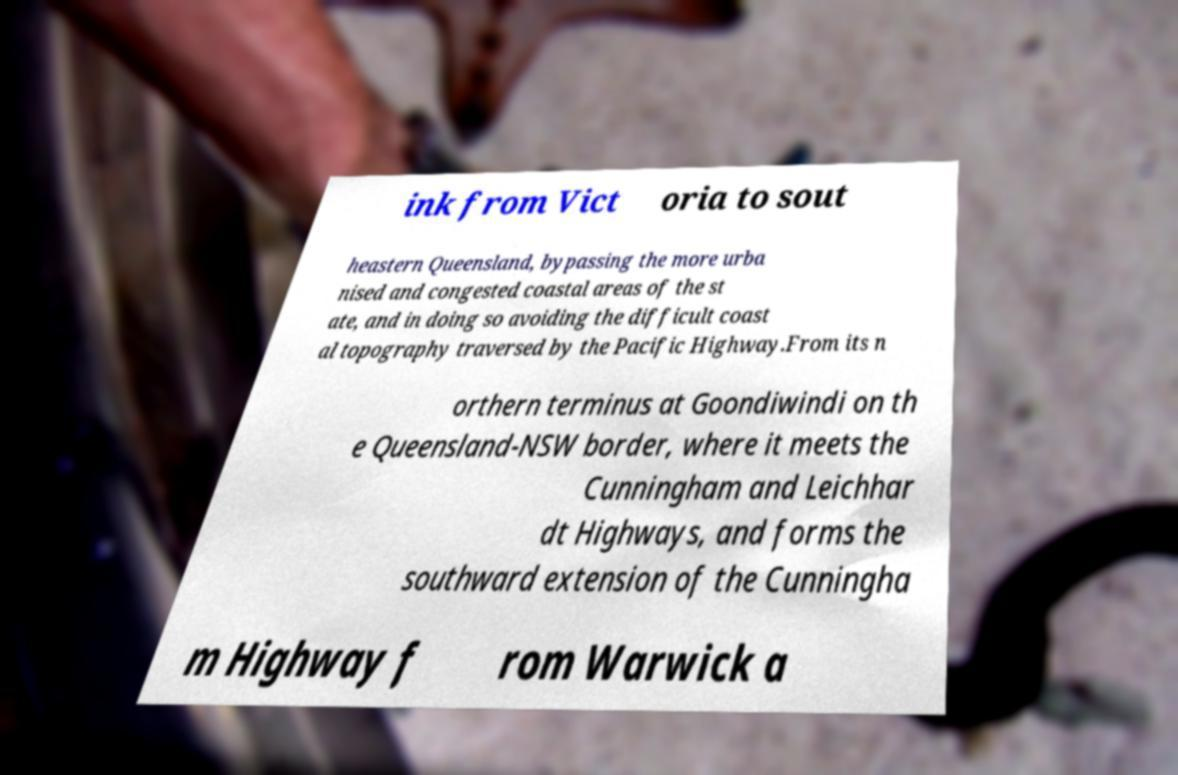What messages or text are displayed in this image? I need them in a readable, typed format. ink from Vict oria to sout heastern Queensland, bypassing the more urba nised and congested coastal areas of the st ate, and in doing so avoiding the difficult coast al topography traversed by the Pacific Highway.From its n orthern terminus at Goondiwindi on th e Queensland-NSW border, where it meets the Cunningham and Leichhar dt Highways, and forms the southward extension of the Cunningha m Highway f rom Warwick a 